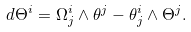Convert formula to latex. <formula><loc_0><loc_0><loc_500><loc_500>d \Theta ^ { i } = \Omega ^ { i } _ { j } \wedge \theta ^ { j } - \theta ^ { i } _ { j } \wedge \Theta ^ { j } .</formula> 